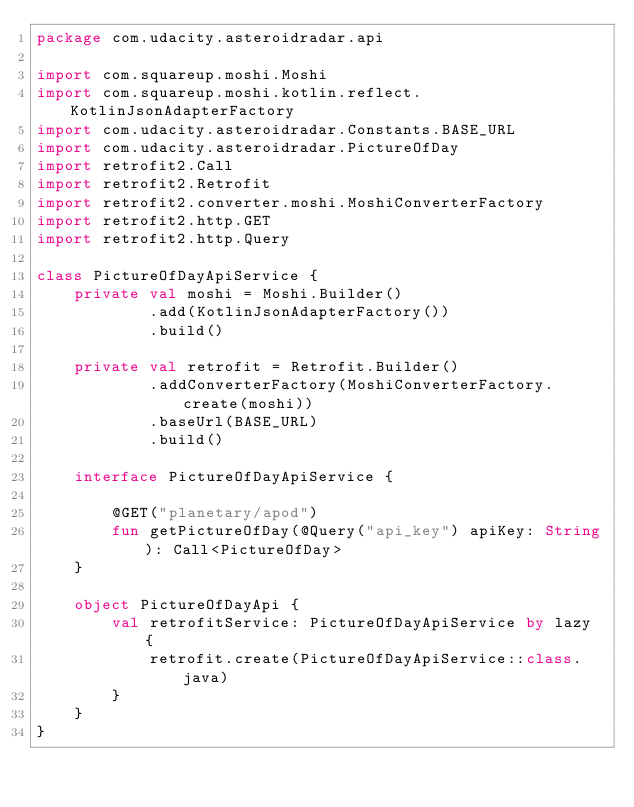Convert code to text. <code><loc_0><loc_0><loc_500><loc_500><_Kotlin_>package com.udacity.asteroidradar.api

import com.squareup.moshi.Moshi
import com.squareup.moshi.kotlin.reflect.KotlinJsonAdapterFactory
import com.udacity.asteroidradar.Constants.BASE_URL
import com.udacity.asteroidradar.PictureOfDay
import retrofit2.Call
import retrofit2.Retrofit
import retrofit2.converter.moshi.MoshiConverterFactory
import retrofit2.http.GET
import retrofit2.http.Query

class PictureOfDayApiService {
    private val moshi = Moshi.Builder()
            .add(KotlinJsonAdapterFactory())
            .build()

    private val retrofit = Retrofit.Builder()
            .addConverterFactory(MoshiConverterFactory.create(moshi))
            .baseUrl(BASE_URL)
            .build()

    interface PictureOfDayApiService {

        @GET("planetary/apod")
        fun getPictureOfDay(@Query("api_key") apiKey: String): Call<PictureOfDay>
    }

    object PictureOfDayApi {
        val retrofitService: PictureOfDayApiService by lazy {
            retrofit.create(PictureOfDayApiService::class.java)
        }
    }
}</code> 